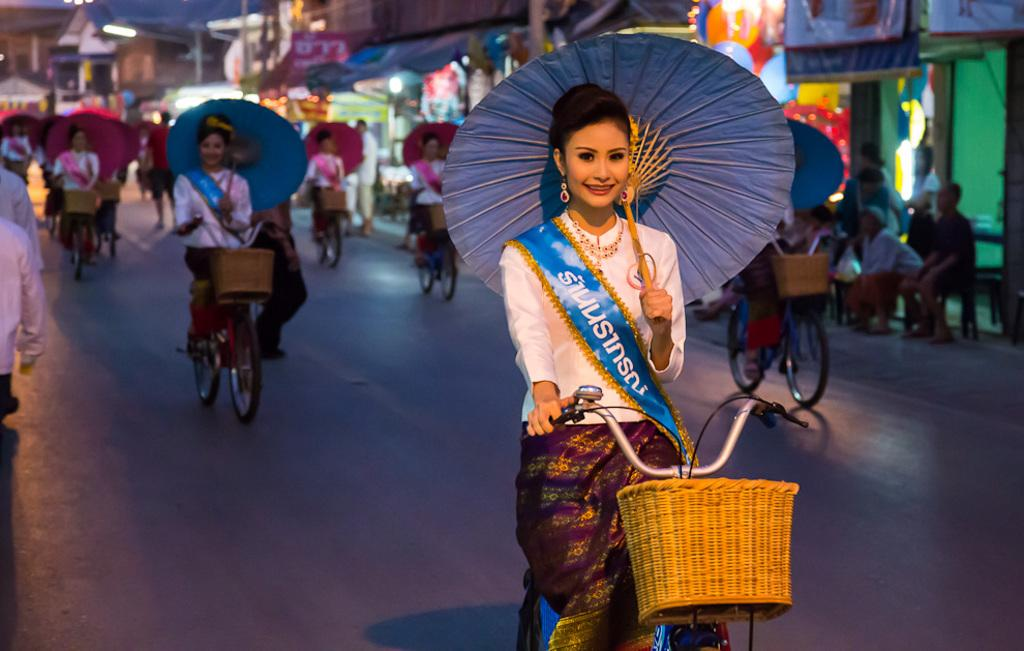Who is present in the image? There are women in the image. What are the women doing in the image? The women are sitting on bicycles. What are the women holding in the image? The women are holding umbrellas. What can be seen in the distance in the image? There are buildings, people, and other objects visible in the background of the image. What type of sponge can be seen in the image? There is no sponge present in the image. Can you tell me how many yaks are visible in the image? There are no yaks visible in the image. 